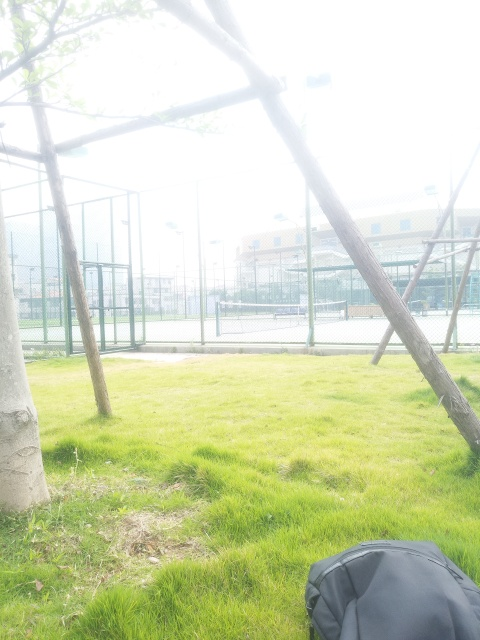How is the lighting in the image?
A. strong
B. balanced
C. dim The lighting in the image is strong, as evidenced by the overexposed areas where the brightness is intense, particularly in the sky and on some of the grassy areas. This can be viewed as imbalanced lighting due to the high contrast between the very bright zones and the properly exposed regions. 